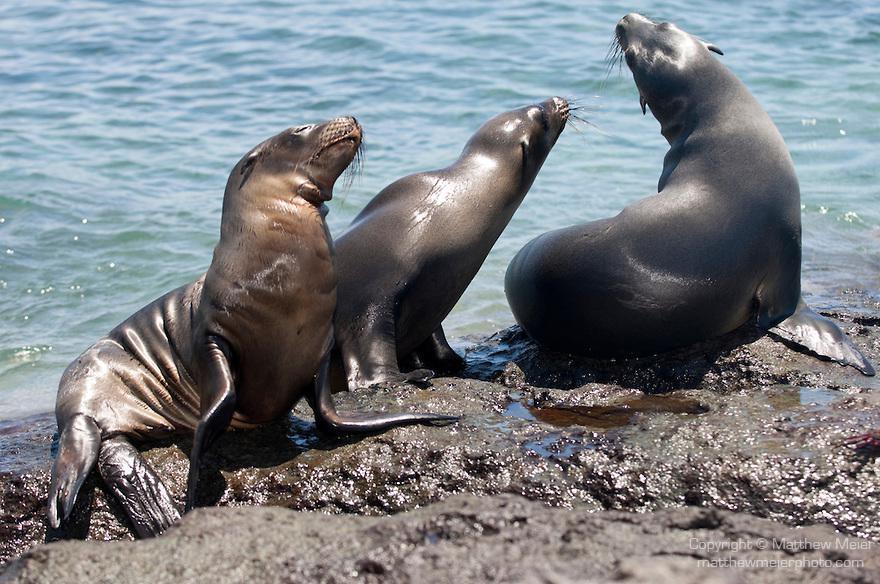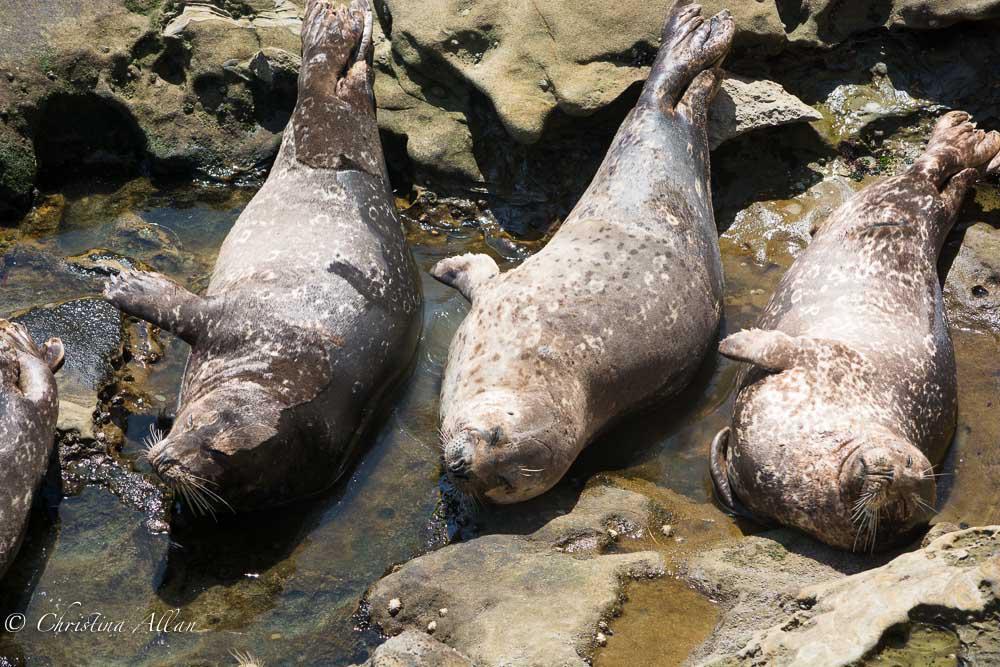The first image is the image on the left, the second image is the image on the right. Analyze the images presented: Is the assertion "There are two sea lions in one of the images." valid? Answer yes or no. No. 